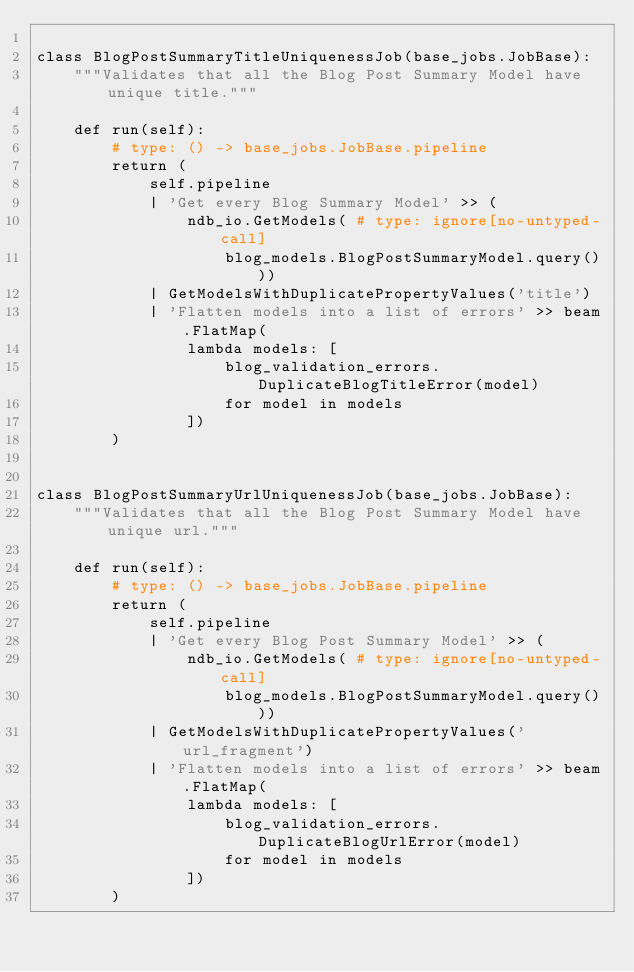<code> <loc_0><loc_0><loc_500><loc_500><_Python_>
class BlogPostSummaryTitleUniquenessJob(base_jobs.JobBase):
    """Validates that all the Blog Post Summary Model have unique title."""

    def run(self):
        # type: () -> base_jobs.JobBase.pipeline
        return (
            self.pipeline
            | 'Get every Blog Summary Model' >> (
                ndb_io.GetModels( # type: ignore[no-untyped-call]
                    blog_models.BlogPostSummaryModel.query()))
            | GetModelsWithDuplicatePropertyValues('title')
            | 'Flatten models into a list of errors' >> beam.FlatMap(
                lambda models: [
                    blog_validation_errors.DuplicateBlogTitleError(model)
                    for model in models
                ])
        )


class BlogPostSummaryUrlUniquenessJob(base_jobs.JobBase):
    """Validates that all the Blog Post Summary Model have unique url."""

    def run(self):
        # type: () -> base_jobs.JobBase.pipeline
        return (
            self.pipeline
            | 'Get every Blog Post Summary Model' >> (
                ndb_io.GetModels( # type: ignore[no-untyped-call]
                    blog_models.BlogPostSummaryModel.query()))
            | GetModelsWithDuplicatePropertyValues('url_fragment')
            | 'Flatten models into a list of errors' >> beam.FlatMap(
                lambda models: [
                    blog_validation_errors.DuplicateBlogUrlError(model)
                    for model in models
                ])
        )
</code> 